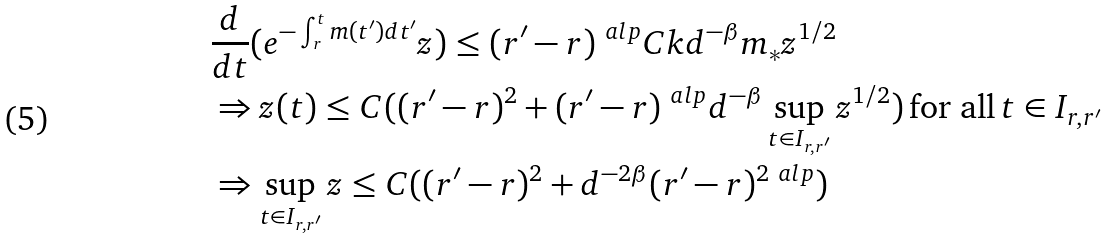<formula> <loc_0><loc_0><loc_500><loc_500>& \frac { d } { d t } ( e ^ { - \int _ { r } ^ { t } m ( t ^ { \prime } ) d t ^ { \prime } } z ) \leq ( r ^ { \prime } - r ) ^ { \ a l p } C k d ^ { - \beta } m _ { * } z ^ { 1 / 2 } \\ & \Rightarrow z ( t ) \leq C ( ( r ^ { \prime } - r ) ^ { 2 } + ( r ^ { \prime } - r ) ^ { \ a l p } d ^ { - \beta } \sup _ { t \in I _ { r , r ^ { \prime } } } z ^ { 1 / 2 } ) \, \text {for all} \, t \in I _ { r , r ^ { \prime } } \\ & \Rightarrow \sup _ { t \in I _ { r , r ^ { \prime } } } z \leq C ( ( r ^ { \prime } - r ) ^ { 2 } + d ^ { - 2 \beta } ( r ^ { \prime } - r ) ^ { 2 \ a l p } )</formula> 